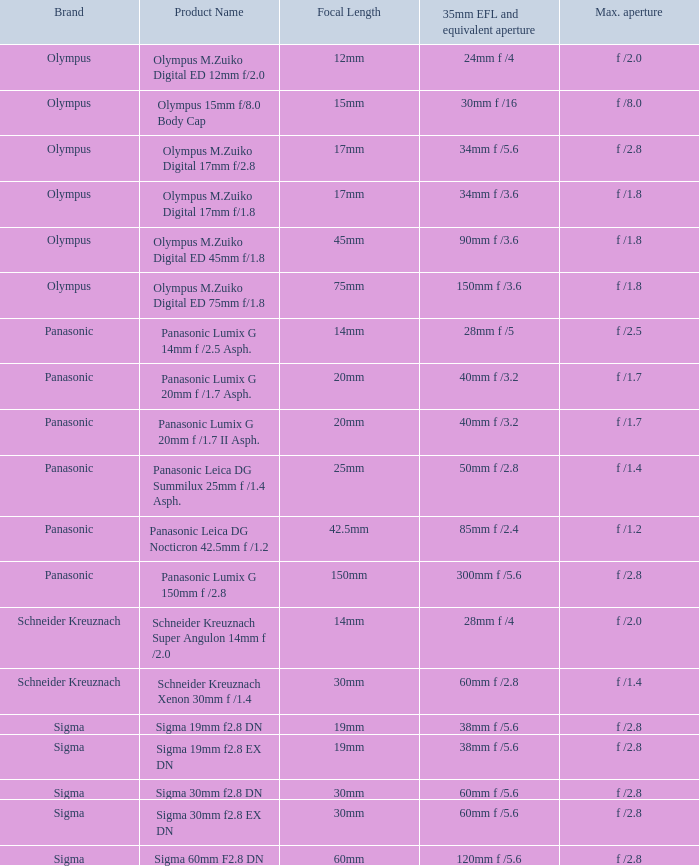For lenses with a 20mm focal length, what is the highest aperture value? F /1.7, f /1.7. Can you parse all the data within this table? {'header': ['Brand', 'Product Name', 'Focal Length', '35mm EFL and equivalent aperture', 'Max. aperture'], 'rows': [['Olympus', 'Olympus M.Zuiko Digital ED 12mm f/2.0', '12mm', '24mm f /4', 'f /2.0'], ['Olympus', 'Olympus 15mm f/8.0 Body Cap', '15mm', '30mm f /16', 'f /8.0'], ['Olympus', 'Olympus M.Zuiko Digital 17mm f/2.8', '17mm', '34mm f /5.6', 'f /2.8'], ['Olympus', 'Olympus M.Zuiko Digital 17mm f/1.8', '17mm', '34mm f /3.6', 'f /1.8'], ['Olympus', 'Olympus M.Zuiko Digital ED 45mm f/1.8', '45mm', '90mm f /3.6', 'f /1.8'], ['Olympus', 'Olympus M.Zuiko Digital ED 75mm f/1.8', '75mm', '150mm f /3.6', 'f /1.8'], ['Panasonic', 'Panasonic Lumix G 14mm f /2.5 Asph.', '14mm', '28mm f /5', 'f /2.5'], ['Panasonic', 'Panasonic Lumix G 20mm f /1.7 Asph.', '20mm', '40mm f /3.2', 'f /1.7'], ['Panasonic', 'Panasonic Lumix G 20mm f /1.7 II Asph.', '20mm', '40mm f /3.2', 'f /1.7'], ['Panasonic', 'Panasonic Leica DG Summilux 25mm f /1.4 Asph.', '25mm', '50mm f /2.8', 'f /1.4'], ['Panasonic', 'Panasonic Leica DG Nocticron 42.5mm f /1.2', '42.5mm', '85mm f /2.4', 'f /1.2'], ['Panasonic', 'Panasonic Lumix G 150mm f /2.8', '150mm', '300mm f /5.6', 'f /2.8'], ['Schneider Kreuznach', 'Schneider Kreuznach Super Angulon 14mm f /2.0', '14mm', '28mm f /4', 'f /2.0'], ['Schneider Kreuznach', 'Schneider Kreuznach Xenon 30mm f /1.4', '30mm', '60mm f /2.8', 'f /1.4'], ['Sigma', 'Sigma 19mm f2.8 DN', '19mm', '38mm f /5.6', 'f /2.8'], ['Sigma', 'Sigma 19mm f2.8 EX DN', '19mm', '38mm f /5.6', 'f /2.8'], ['Sigma', 'Sigma 30mm f2.8 DN', '30mm', '60mm f /5.6', 'f /2.8'], ['Sigma', 'Sigma 30mm f2.8 EX DN', '30mm', '60mm f /5.6', 'f /2.8'], ['Sigma', 'Sigma 60mm F2.8 DN', '60mm', '120mm f /5.6', 'f /2.8']]} 